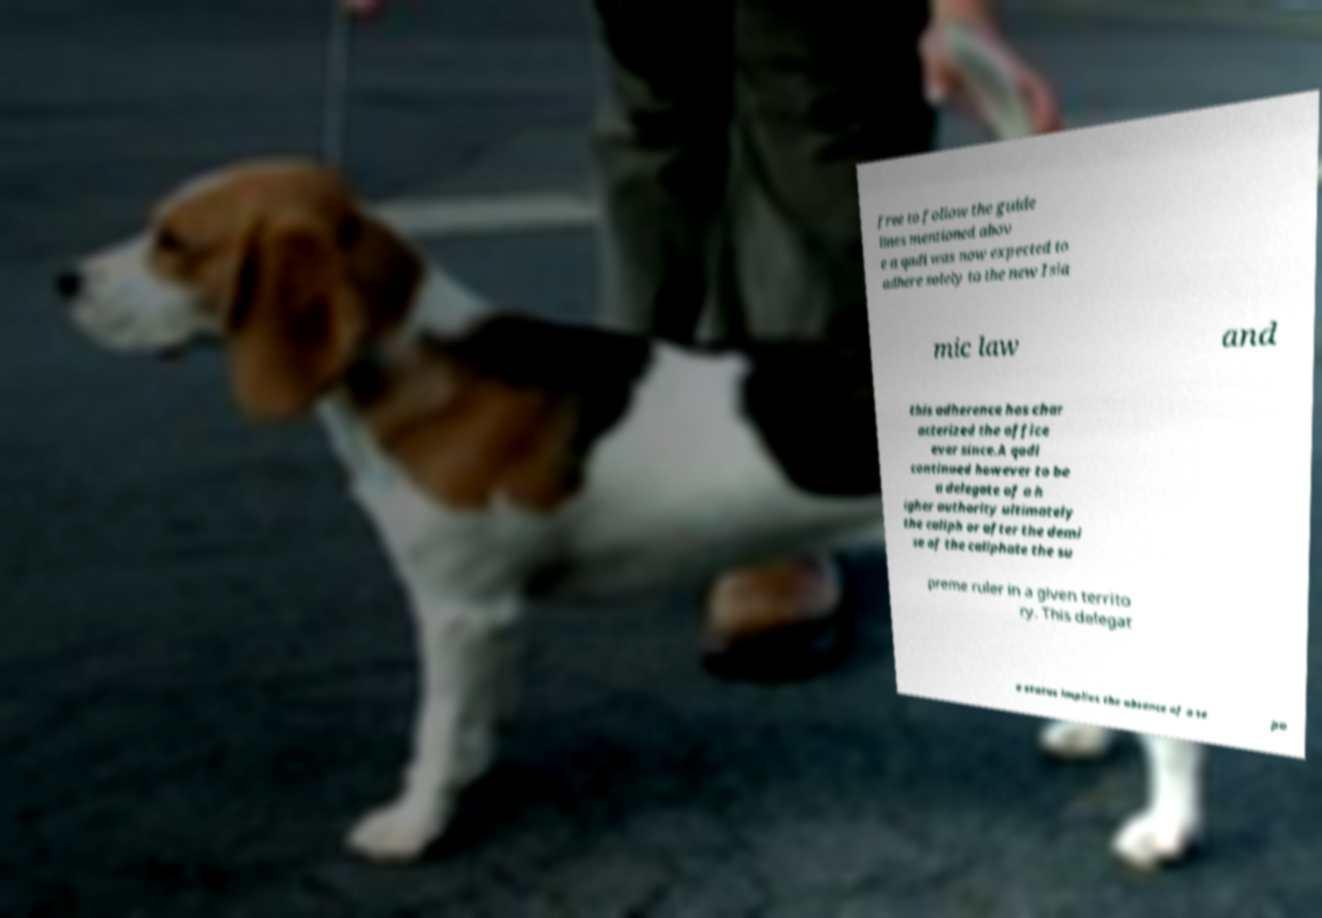For documentation purposes, I need the text within this image transcribed. Could you provide that? free to follow the guide lines mentioned abov e a qadi was now expected to adhere solely to the new Isla mic law and this adherence has char acterized the office ever since.A qadi continued however to be a delegate of a h igher authority ultimately the caliph or after the demi se of the caliphate the su preme ruler in a given territo ry. This delegat e status implies the absence of a se pa 